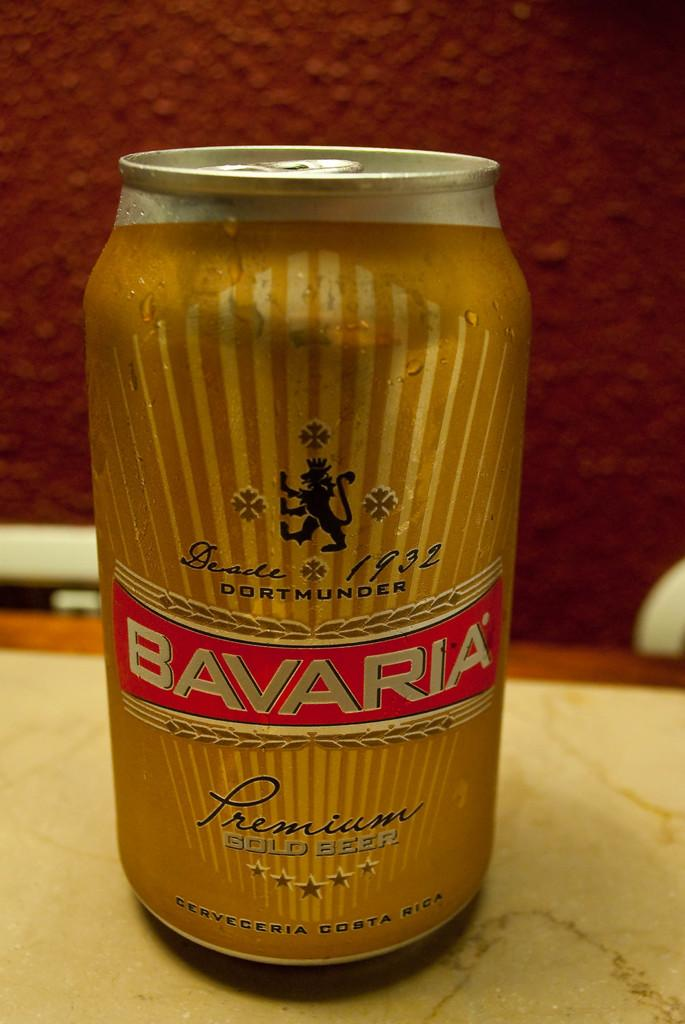<image>
Offer a succinct explanation of the picture presented. A simple image of a yellow can of Bavaria Lager. 